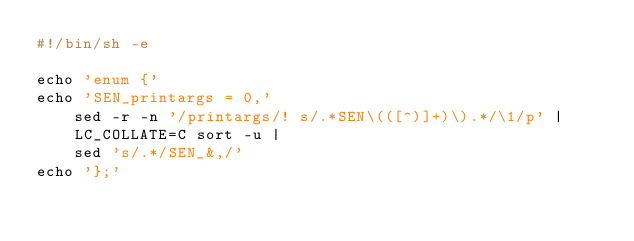Convert code to text. <code><loc_0><loc_0><loc_500><loc_500><_Bash_>#!/bin/sh -e

echo 'enum {'
echo 'SEN_printargs = 0,'
    sed -r -n '/printargs/! s/.*SEN\(([^)]+)\).*/\1/p' |
    LC_COLLATE=C sort -u |
    sed 's/.*/SEN_&,/'
echo '};'
</code> 